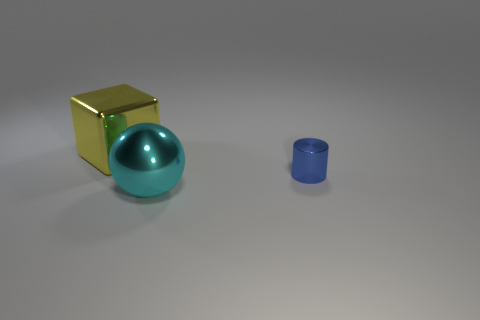Add 3 big brown metal cylinders. How many objects exist? 6 Add 1 yellow shiny cubes. How many yellow shiny cubes are left? 2 Add 3 large blue metal cylinders. How many large blue metal cylinders exist? 3 Subtract 1 yellow cubes. How many objects are left? 2 Subtract all cylinders. How many objects are left? 2 Subtract all cyan spheres. Subtract all cyan metal things. How many objects are left? 1 